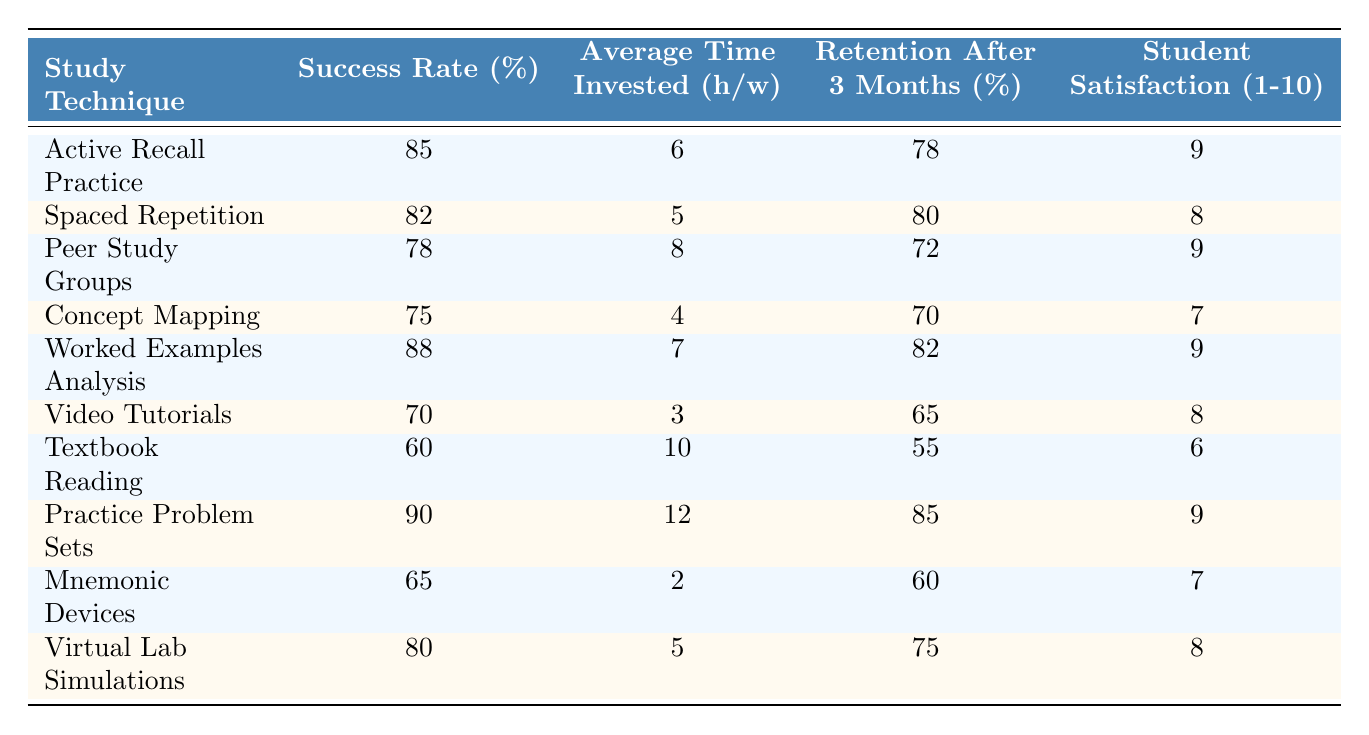What is the success rate of the "Worked Examples Analysis" technique? The table shows that the success rate for "Worked Examples Analysis" is 88%.
Answer: 88% Which study technique has the highest average time invested per week? By looking at the table, "Practice Problem Sets" has the highest average time invested at 12 hours per week.
Answer: 12 hours How does the success rate of "Active Recall Practice" compare to "Textbook Reading"? "Active Recall Practice" has a success rate of 85%, while "Textbook Reading" has a success rate of 60%. The difference is 85% - 60% = 25%.
Answer: 25% What is the average retention rate for all study techniques listed? To find the average retention rate, we sum the retention rates: 78 + 80 + 72 + 70 + 82 + 65 + 55 + 85 + 60 + 75 =  82. The total is  82 / 10 = 78.2%.
Answer: 78.2% Is the student satisfaction for "Video Tutorials" greater than that for "Mnemonic Devices"? "Video Tutorials" has a satisfaction score of 8, while "Mnemonic Devices" has a score of 7. Therefore, yes, the satisfaction for "Video Tutorials" is greater.
Answer: Yes Which study technique shows the lowest success rate, and what is that rate? The table indicates that "Textbook Reading" has the lowest success rate at 60%.
Answer: 60% Calculate the difference in student satisfaction between the highest and lowest technique. The highest satisfaction score is 9 (for "Active Recall Practice", "Peer Study Groups", "Worked Examples Analysis", and "Practice Problem Sets"), and the lowest is 6 ("Textbook Reading"). The difference is 9 - 6 = 3.
Answer: 3 Are students more satisfied with "Concept Mapping" or "Virtual Lab Simulations"? "Concept Mapping" has a satisfaction score of 7, while "Virtual Lab Simulations" has a score of 8. Thus, students are more satisfied with "Virtual Lab Simulations".
Answer: Virtual Lab Simulations What study technique has a success rate of 70% or higher and requires less than 6 hours of investment weekly? Looking at the table, the "Spaced Repetition" and "Virtual Lab Simulations" techniques have success rates of 82% and 80% respectively, both requiring 5 hours weekly or less.
Answer: Spaced Repetition, Virtual Lab Simulations What is the average success rate for the top three study techniques? The top three techniques are "Practice Problem Sets" (90%), "Worked Examples Analysis" (88%), and "Active Recall Practice" (85%). The average is (90 + 88 + 85) / 3 = 87.67%.
Answer: 87.67% 